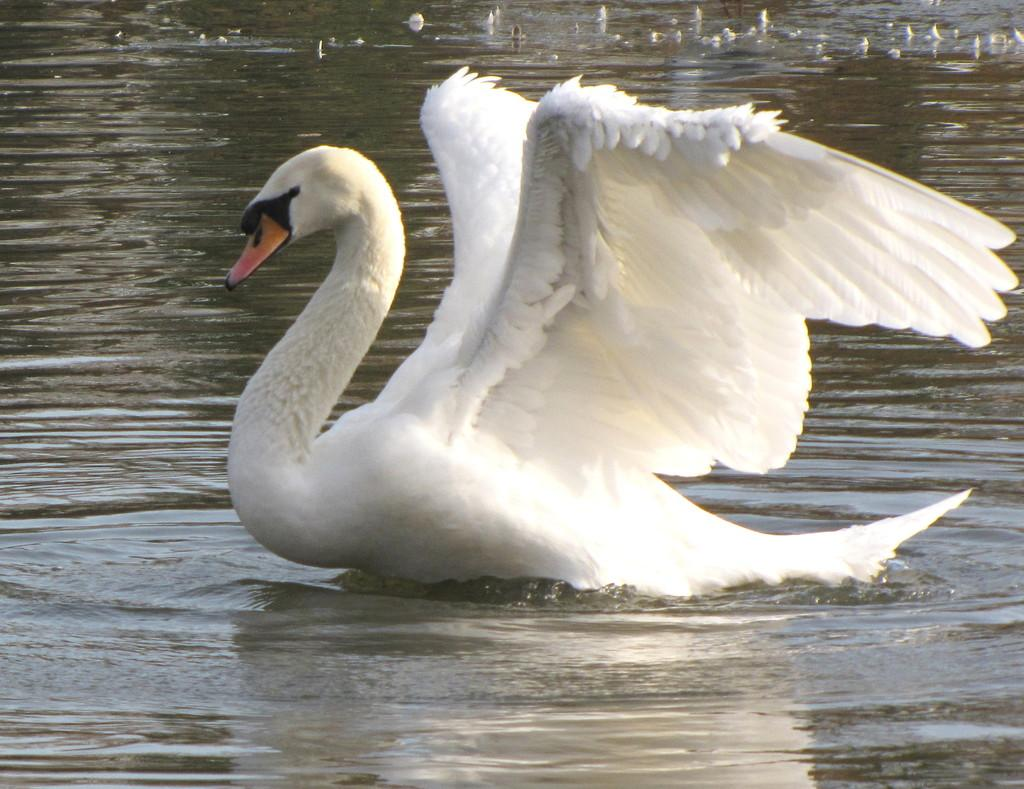What animal is present in the image? There is a swan in the image. Where is the swan located? The swan is on the water. Can you see the swan rooting in the image? There is no rooting activity depicted in the image, as swans do not have the ability to root. 